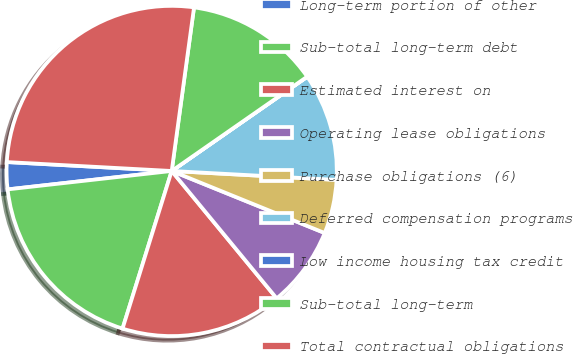Convert chart to OTSL. <chart><loc_0><loc_0><loc_500><loc_500><pie_chart><fcel>Long-term portion of other<fcel>Sub-total long-term debt<fcel>Estimated interest on<fcel>Operating lease obligations<fcel>Purchase obligations (6)<fcel>Deferred compensation programs<fcel>Low income housing tax credit<fcel>Sub-total long-term<fcel>Total contractual obligations<nl><fcel>2.64%<fcel>18.41%<fcel>15.78%<fcel>7.9%<fcel>5.27%<fcel>10.53%<fcel>0.01%<fcel>13.16%<fcel>26.3%<nl></chart> 